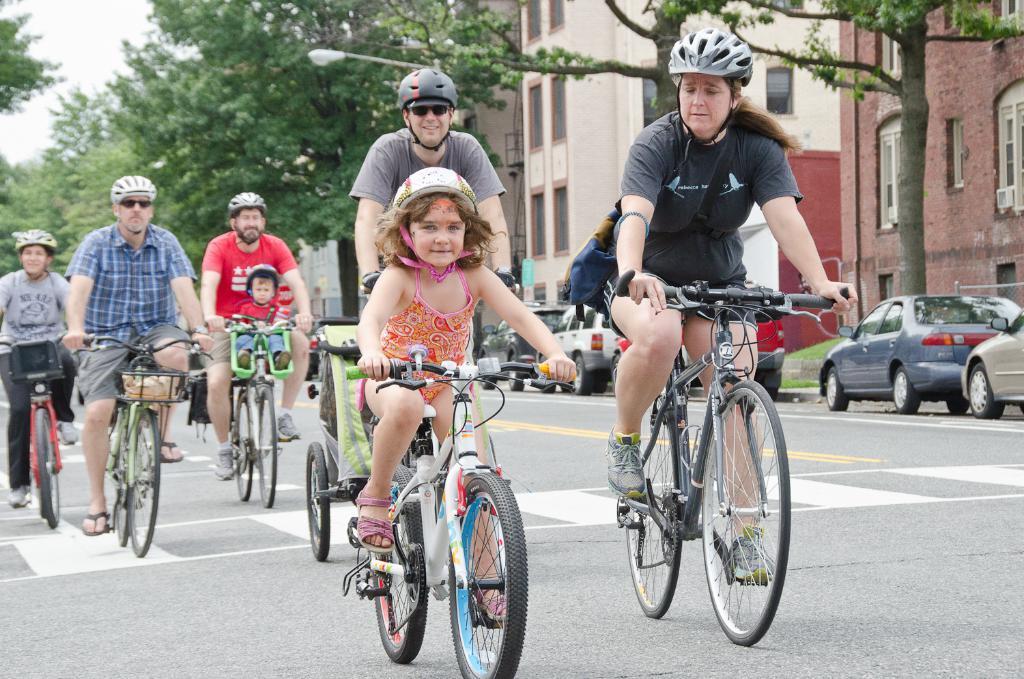How would you summarize this image in a sentence or two? In this picture we can see a group of people where they wore helmets and riding bicycle on road and aside to this road we have see cars and in background we can see building with windows, trees, light, sky. 